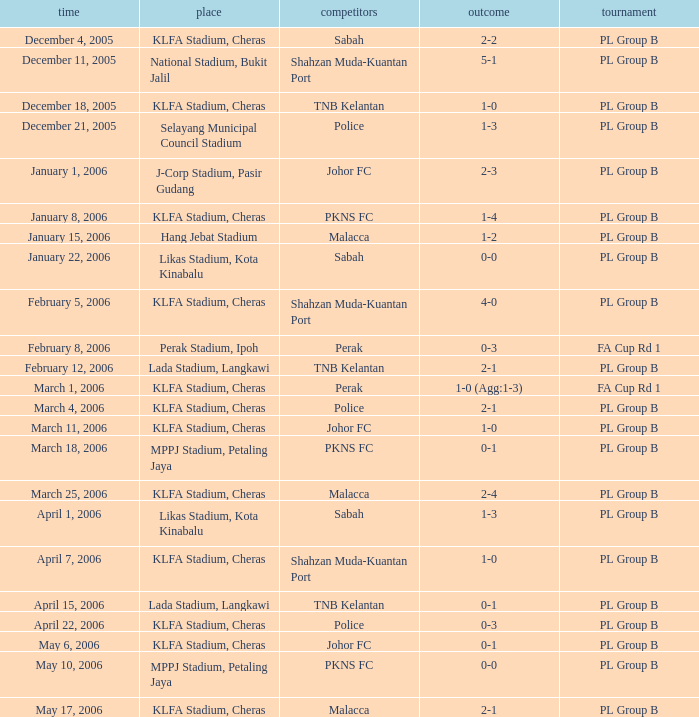Which Score has Opponents of pkns fc, and a Date of january 8, 2006? 1-4. 